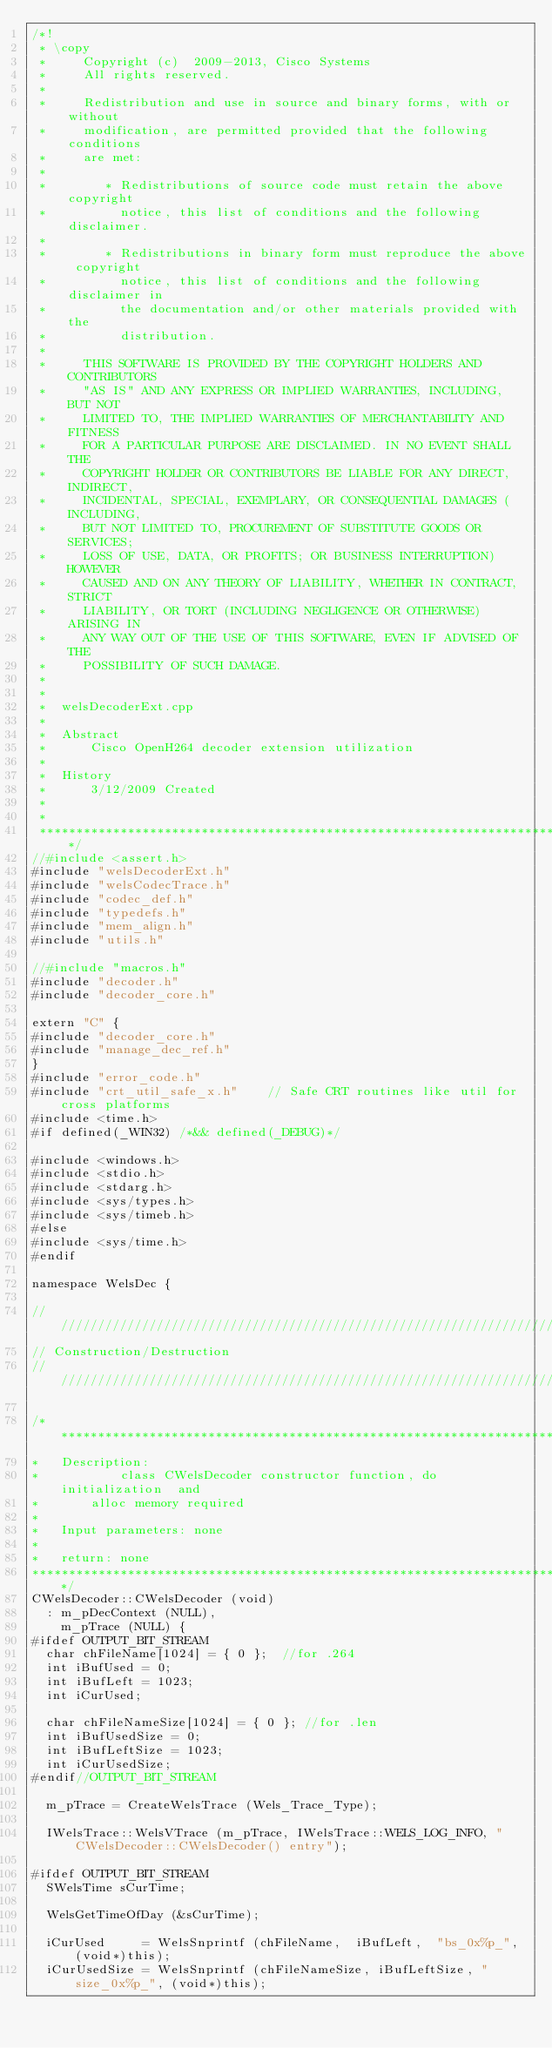<code> <loc_0><loc_0><loc_500><loc_500><_C++_>/*!
 * \copy
 *     Copyright (c)  2009-2013, Cisco Systems
 *     All rights reserved.
 *
 *     Redistribution and use in source and binary forms, with or without
 *     modification, are permitted provided that the following conditions
 *     are met:
 *
 *        * Redistributions of source code must retain the above copyright
 *          notice, this list of conditions and the following disclaimer.
 *
 *        * Redistributions in binary form must reproduce the above copyright
 *          notice, this list of conditions and the following disclaimer in
 *          the documentation and/or other materials provided with the
 *          distribution.
 *
 *     THIS SOFTWARE IS PROVIDED BY THE COPYRIGHT HOLDERS AND CONTRIBUTORS
 *     "AS IS" AND ANY EXPRESS OR IMPLIED WARRANTIES, INCLUDING, BUT NOT
 *     LIMITED TO, THE IMPLIED WARRANTIES OF MERCHANTABILITY AND FITNESS
 *     FOR A PARTICULAR PURPOSE ARE DISCLAIMED. IN NO EVENT SHALL THE
 *     COPYRIGHT HOLDER OR CONTRIBUTORS BE LIABLE FOR ANY DIRECT, INDIRECT,
 *     INCIDENTAL, SPECIAL, EXEMPLARY, OR CONSEQUENTIAL DAMAGES (INCLUDING,
 *     BUT NOT LIMITED TO, PROCUREMENT OF SUBSTITUTE GOODS OR SERVICES;
 *     LOSS OF USE, DATA, OR PROFITS; OR BUSINESS INTERRUPTION) HOWEVER
 *     CAUSED AND ON ANY THEORY OF LIABILITY, WHETHER IN CONTRACT, STRICT
 *     LIABILITY, OR TORT (INCLUDING NEGLIGENCE OR OTHERWISE) ARISING IN
 *     ANY WAY OUT OF THE USE OF THIS SOFTWARE, EVEN IF ADVISED OF THE
 *     POSSIBILITY OF SUCH DAMAGE.
 *
 *
 *  welsDecoderExt.cpp
 *
 *  Abstract
 *      Cisco OpenH264 decoder extension utilization
 *
 *  History
 *      3/12/2009 Created
 *
 *
 ************************************************************************/
//#include <assert.h>
#include "welsDecoderExt.h"
#include "welsCodecTrace.h"
#include "codec_def.h"
#include "typedefs.h"
#include "mem_align.h"
#include "utils.h"

//#include "macros.h"
#include "decoder.h"
#include "decoder_core.h"

extern "C" {
#include "decoder_core.h"
#include "manage_dec_ref.h"
}
#include "error_code.h"
#include "crt_util_safe_x.h"	// Safe CRT routines like util for cross platforms
#include <time.h>
#if defined(_WIN32) /*&& defined(_DEBUG)*/

#include <windows.h>
#include <stdio.h>
#include <stdarg.h>
#include <sys/types.h>
#include <sys/timeb.h>
#else
#include <sys/time.h>
#endif

namespace WelsDec {

//////////////////////////////////////////////////////////////////////
// Construction/Destruction
//////////////////////////////////////////////////////////////////////

/***************************************************************************
*	Description:
*			class CWelsDecoder constructor function, do initialization	and
*       alloc memory required
*
*	Input parameters: none
*
*	return: none
***************************************************************************/
CWelsDecoder::CWelsDecoder (void)
  :	m_pDecContext (NULL),
    m_pTrace (NULL) {
#ifdef OUTPUT_BIT_STREAM
  char chFileName[1024] = { 0 };  //for .264
  int iBufUsed = 0;
  int iBufLeft = 1023;
  int iCurUsed;

  char chFileNameSize[1024] = { 0 }; //for .len
  int iBufUsedSize = 0;
  int iBufLeftSize = 1023;
  int iCurUsedSize;
#endif//OUTPUT_BIT_STREAM

  m_pTrace = CreateWelsTrace (Wels_Trace_Type);

  IWelsTrace::WelsVTrace (m_pTrace, IWelsTrace::WELS_LOG_INFO, "CWelsDecoder::CWelsDecoder() entry");

#ifdef OUTPUT_BIT_STREAM
  SWelsTime sCurTime;

  WelsGetTimeOfDay (&sCurTime);

  iCurUsed     = WelsSnprintf (chFileName,  iBufLeft,  "bs_0x%p_", (void*)this);
  iCurUsedSize = WelsSnprintf (chFileNameSize, iBufLeftSize, "size_0x%p_", (void*)this);
</code> 